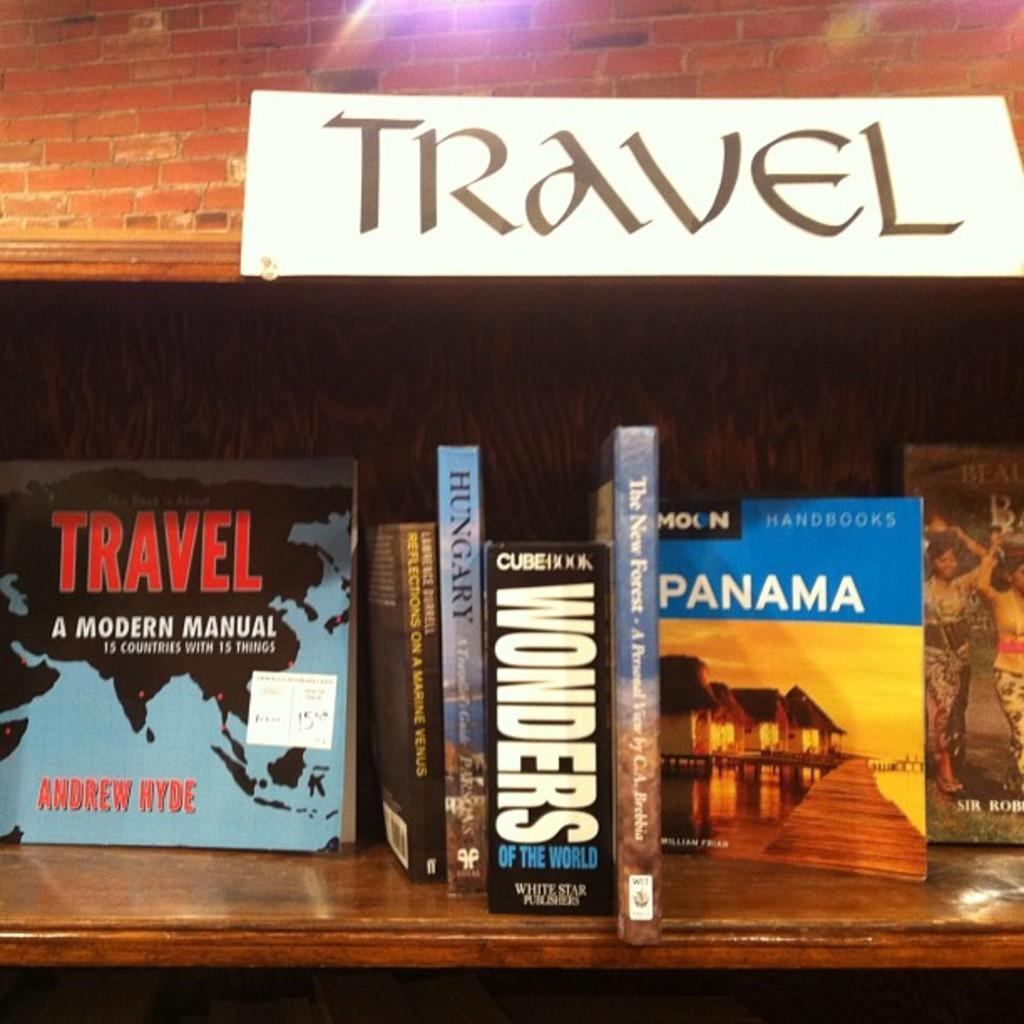<image>
Share a concise interpretation of the image provided. Travel related books, including the titles Hungary, Wonders of the World and The New Forest. 